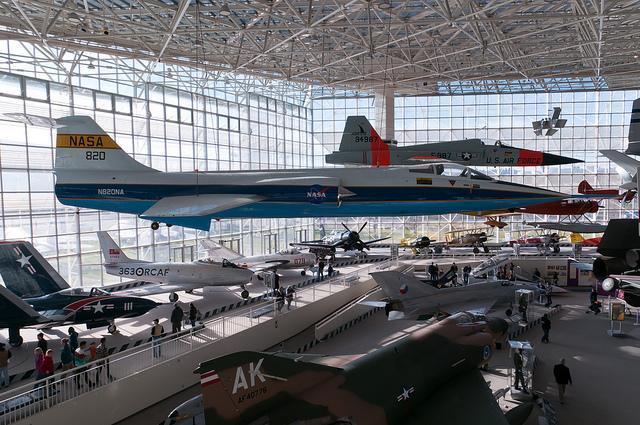How many airplanes are there?
Give a very brief answer. 6. 